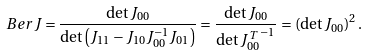<formula> <loc_0><loc_0><loc_500><loc_500>\ B e r J = \frac { \det J _ { 0 0 } } { \det \left ( J _ { 1 1 } - J _ { 1 0 } J _ { 0 0 } ^ { - 1 } J _ { 0 1 } \right ) } = \frac { \det J _ { 0 0 } } { \det { J _ { 0 0 } ^ { \, T } } ^ { - 1 } } = \left ( \det J _ { 0 0 } \right ) ^ { 2 } .</formula> 